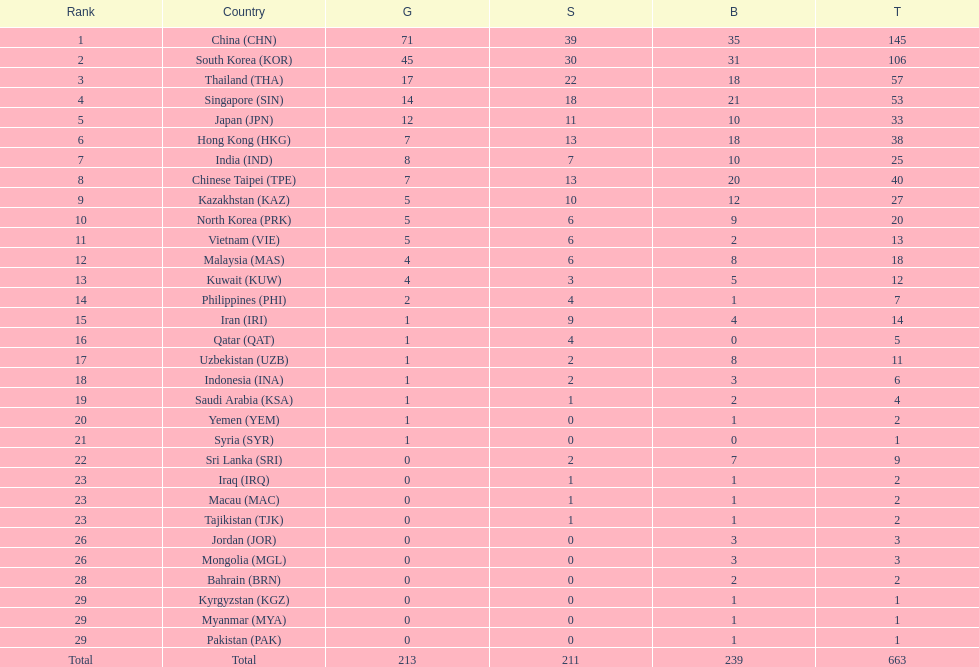Which countries have the same number of silver medals in the asian youth games as north korea? Vietnam (VIE), Malaysia (MAS). 